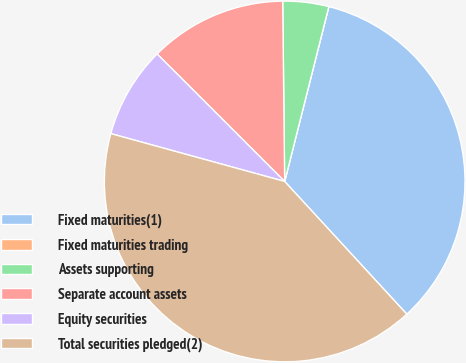Convert chart to OTSL. <chart><loc_0><loc_0><loc_500><loc_500><pie_chart><fcel>Fixed maturities(1)<fcel>Fixed maturities trading<fcel>Assets supporting<fcel>Separate account assets<fcel>Equity securities<fcel>Total securities pledged(2)<nl><fcel>34.22%<fcel>0.0%<fcel>4.11%<fcel>12.33%<fcel>8.22%<fcel>41.11%<nl></chart> 